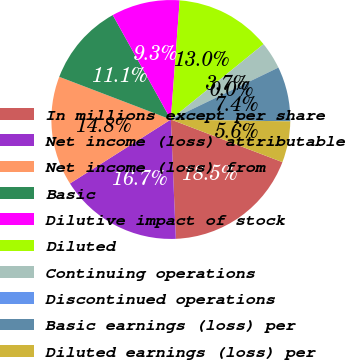<chart> <loc_0><loc_0><loc_500><loc_500><pie_chart><fcel>In millions except per share<fcel>Net income (loss) attributable<fcel>Net income (loss) from<fcel>Basic<fcel>Dilutive impact of stock<fcel>Diluted<fcel>Continuing operations<fcel>Discontinued operations<fcel>Basic earnings (loss) per<fcel>Diluted earnings (loss) per<nl><fcel>18.52%<fcel>16.67%<fcel>14.81%<fcel>11.11%<fcel>9.26%<fcel>12.96%<fcel>3.7%<fcel>0.0%<fcel>7.41%<fcel>5.56%<nl></chart> 